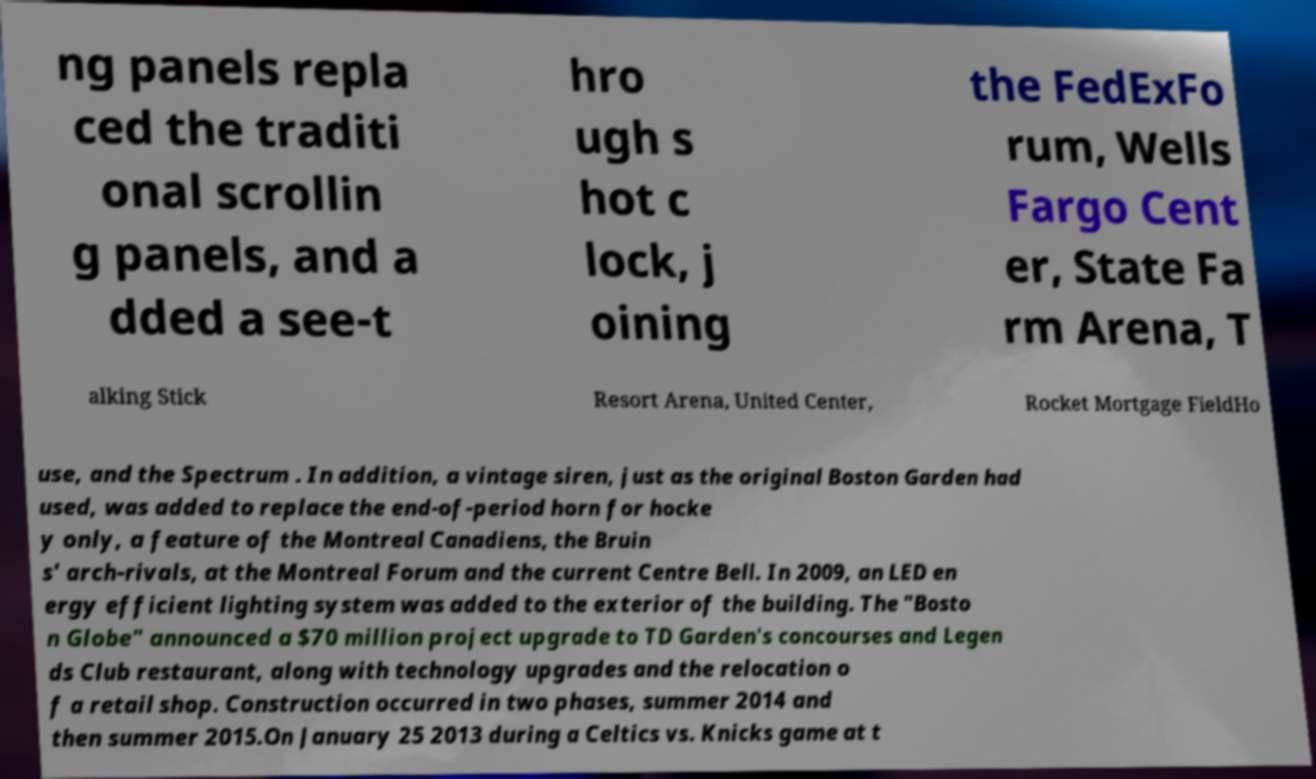Could you assist in decoding the text presented in this image and type it out clearly? ng panels repla ced the traditi onal scrollin g panels, and a dded a see-t hro ugh s hot c lock, j oining the FedExFo rum, Wells Fargo Cent er, State Fa rm Arena, T alking Stick Resort Arena, United Center, Rocket Mortgage FieldHo use, and the Spectrum . In addition, a vintage siren, just as the original Boston Garden had used, was added to replace the end-of-period horn for hocke y only, a feature of the Montreal Canadiens, the Bruin s' arch-rivals, at the Montreal Forum and the current Centre Bell. In 2009, an LED en ergy efficient lighting system was added to the exterior of the building. The "Bosto n Globe" announced a $70 million project upgrade to TD Garden's concourses and Legen ds Club restaurant, along with technology upgrades and the relocation o f a retail shop. Construction occurred in two phases, summer 2014 and then summer 2015.On January 25 2013 during a Celtics vs. Knicks game at t 